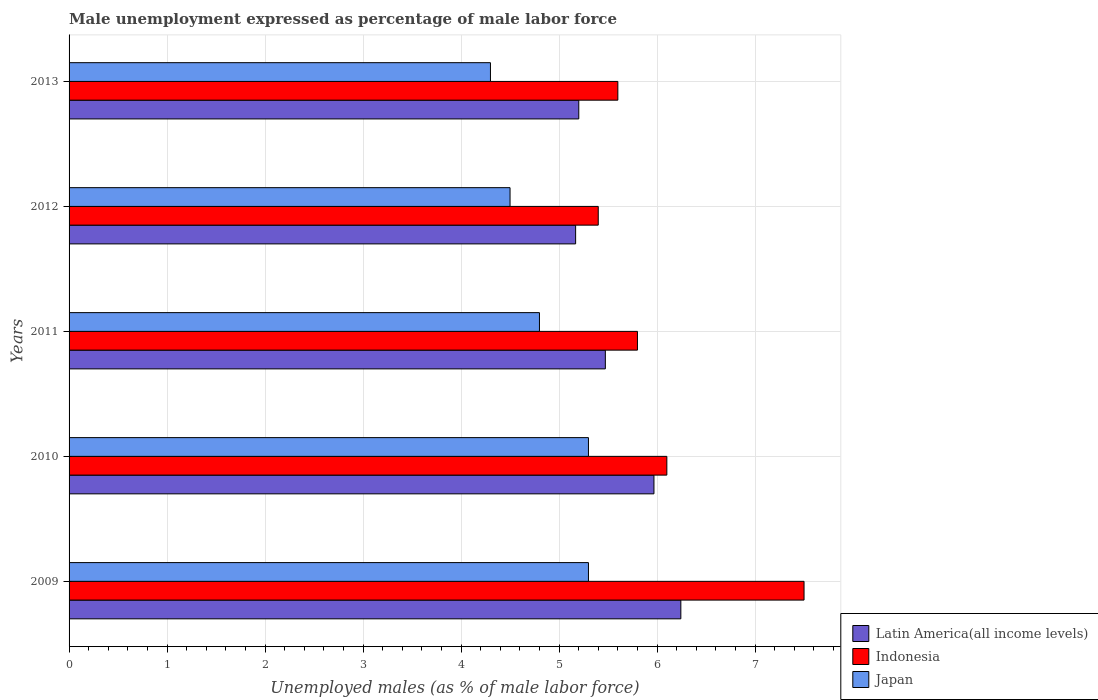How many groups of bars are there?
Offer a terse response. 5. Are the number of bars on each tick of the Y-axis equal?
Your answer should be compact. Yes. How many bars are there on the 4th tick from the bottom?
Give a very brief answer. 3. What is the label of the 4th group of bars from the top?
Your answer should be compact. 2010. In how many cases, is the number of bars for a given year not equal to the number of legend labels?
Your answer should be compact. 0. What is the unemployment in males in in Japan in 2011?
Offer a terse response. 4.8. Across all years, what is the maximum unemployment in males in in Japan?
Your response must be concise. 5.3. Across all years, what is the minimum unemployment in males in in Indonesia?
Make the answer very short. 5.4. In which year was the unemployment in males in in Japan maximum?
Provide a short and direct response. 2009. In which year was the unemployment in males in in Latin America(all income levels) minimum?
Your response must be concise. 2012. What is the total unemployment in males in in Latin America(all income levels) in the graph?
Your answer should be compact. 28.05. What is the difference between the unemployment in males in in Japan in 2010 and the unemployment in males in in Indonesia in 2011?
Give a very brief answer. -0.5. What is the average unemployment in males in in Japan per year?
Offer a terse response. 4.84. In the year 2013, what is the difference between the unemployment in males in in Indonesia and unemployment in males in in Japan?
Ensure brevity in your answer.  1.3. In how many years, is the unemployment in males in in Latin America(all income levels) greater than 3.4 %?
Provide a succinct answer. 5. What is the ratio of the unemployment in males in in Indonesia in 2011 to that in 2012?
Offer a very short reply. 1.07. Is the unemployment in males in in Indonesia in 2009 less than that in 2010?
Your response must be concise. No. Is the difference between the unemployment in males in in Indonesia in 2011 and 2012 greater than the difference between the unemployment in males in in Japan in 2011 and 2012?
Your response must be concise. Yes. What is the difference between the highest and the second highest unemployment in males in in Japan?
Give a very brief answer. 0. What is the difference between the highest and the lowest unemployment in males in in Indonesia?
Your response must be concise. 2.1. In how many years, is the unemployment in males in in Indonesia greater than the average unemployment in males in in Indonesia taken over all years?
Give a very brief answer. 2. What does the 3rd bar from the top in 2010 represents?
Your response must be concise. Latin America(all income levels). How many bars are there?
Ensure brevity in your answer.  15. How many years are there in the graph?
Keep it short and to the point. 5. What is the difference between two consecutive major ticks on the X-axis?
Provide a short and direct response. 1. Where does the legend appear in the graph?
Give a very brief answer. Bottom right. How are the legend labels stacked?
Make the answer very short. Vertical. What is the title of the graph?
Provide a succinct answer. Male unemployment expressed as percentage of male labor force. Does "Micronesia" appear as one of the legend labels in the graph?
Provide a succinct answer. No. What is the label or title of the X-axis?
Ensure brevity in your answer.  Unemployed males (as % of male labor force). What is the Unemployed males (as % of male labor force) of Latin America(all income levels) in 2009?
Offer a terse response. 6.24. What is the Unemployed males (as % of male labor force) in Japan in 2009?
Ensure brevity in your answer.  5.3. What is the Unemployed males (as % of male labor force) in Latin America(all income levels) in 2010?
Your answer should be compact. 5.97. What is the Unemployed males (as % of male labor force) in Indonesia in 2010?
Your answer should be compact. 6.1. What is the Unemployed males (as % of male labor force) of Japan in 2010?
Provide a short and direct response. 5.3. What is the Unemployed males (as % of male labor force) in Latin America(all income levels) in 2011?
Provide a succinct answer. 5.47. What is the Unemployed males (as % of male labor force) in Indonesia in 2011?
Give a very brief answer. 5.8. What is the Unemployed males (as % of male labor force) of Japan in 2011?
Your answer should be very brief. 4.8. What is the Unemployed males (as % of male labor force) of Latin America(all income levels) in 2012?
Provide a succinct answer. 5.17. What is the Unemployed males (as % of male labor force) of Indonesia in 2012?
Make the answer very short. 5.4. What is the Unemployed males (as % of male labor force) in Latin America(all income levels) in 2013?
Make the answer very short. 5.2. What is the Unemployed males (as % of male labor force) in Indonesia in 2013?
Offer a very short reply. 5.6. What is the Unemployed males (as % of male labor force) of Japan in 2013?
Give a very brief answer. 4.3. Across all years, what is the maximum Unemployed males (as % of male labor force) of Latin America(all income levels)?
Offer a terse response. 6.24. Across all years, what is the maximum Unemployed males (as % of male labor force) of Indonesia?
Offer a terse response. 7.5. Across all years, what is the maximum Unemployed males (as % of male labor force) in Japan?
Your response must be concise. 5.3. Across all years, what is the minimum Unemployed males (as % of male labor force) of Latin America(all income levels)?
Your response must be concise. 5.17. Across all years, what is the minimum Unemployed males (as % of male labor force) of Indonesia?
Offer a very short reply. 5.4. Across all years, what is the minimum Unemployed males (as % of male labor force) of Japan?
Your response must be concise. 4.3. What is the total Unemployed males (as % of male labor force) of Latin America(all income levels) in the graph?
Offer a very short reply. 28.05. What is the total Unemployed males (as % of male labor force) in Indonesia in the graph?
Provide a succinct answer. 30.4. What is the total Unemployed males (as % of male labor force) in Japan in the graph?
Provide a succinct answer. 24.2. What is the difference between the Unemployed males (as % of male labor force) of Latin America(all income levels) in 2009 and that in 2010?
Offer a very short reply. 0.27. What is the difference between the Unemployed males (as % of male labor force) in Japan in 2009 and that in 2010?
Your answer should be very brief. 0. What is the difference between the Unemployed males (as % of male labor force) in Latin America(all income levels) in 2009 and that in 2011?
Your answer should be very brief. 0.77. What is the difference between the Unemployed males (as % of male labor force) of Indonesia in 2009 and that in 2011?
Give a very brief answer. 1.7. What is the difference between the Unemployed males (as % of male labor force) in Japan in 2009 and that in 2011?
Make the answer very short. 0.5. What is the difference between the Unemployed males (as % of male labor force) of Latin America(all income levels) in 2009 and that in 2012?
Give a very brief answer. 1.07. What is the difference between the Unemployed males (as % of male labor force) of Indonesia in 2009 and that in 2012?
Make the answer very short. 2.1. What is the difference between the Unemployed males (as % of male labor force) of Japan in 2009 and that in 2012?
Offer a very short reply. 0.8. What is the difference between the Unemployed males (as % of male labor force) in Latin America(all income levels) in 2009 and that in 2013?
Your answer should be very brief. 1.04. What is the difference between the Unemployed males (as % of male labor force) in Indonesia in 2009 and that in 2013?
Make the answer very short. 1.9. What is the difference between the Unemployed males (as % of male labor force) of Latin America(all income levels) in 2010 and that in 2011?
Offer a very short reply. 0.5. What is the difference between the Unemployed males (as % of male labor force) in Latin America(all income levels) in 2010 and that in 2012?
Keep it short and to the point. 0.8. What is the difference between the Unemployed males (as % of male labor force) of Japan in 2010 and that in 2012?
Make the answer very short. 0.8. What is the difference between the Unemployed males (as % of male labor force) of Latin America(all income levels) in 2010 and that in 2013?
Make the answer very short. 0.77. What is the difference between the Unemployed males (as % of male labor force) of Indonesia in 2010 and that in 2013?
Keep it short and to the point. 0.5. What is the difference between the Unemployed males (as % of male labor force) of Japan in 2010 and that in 2013?
Your answer should be compact. 1. What is the difference between the Unemployed males (as % of male labor force) in Latin America(all income levels) in 2011 and that in 2012?
Ensure brevity in your answer.  0.3. What is the difference between the Unemployed males (as % of male labor force) in Indonesia in 2011 and that in 2012?
Your answer should be very brief. 0.4. What is the difference between the Unemployed males (as % of male labor force) in Japan in 2011 and that in 2012?
Offer a very short reply. 0.3. What is the difference between the Unemployed males (as % of male labor force) in Latin America(all income levels) in 2011 and that in 2013?
Your answer should be very brief. 0.27. What is the difference between the Unemployed males (as % of male labor force) in Japan in 2011 and that in 2013?
Offer a terse response. 0.5. What is the difference between the Unemployed males (as % of male labor force) of Latin America(all income levels) in 2012 and that in 2013?
Make the answer very short. -0.03. What is the difference between the Unemployed males (as % of male labor force) in Indonesia in 2012 and that in 2013?
Your answer should be very brief. -0.2. What is the difference between the Unemployed males (as % of male labor force) in Japan in 2012 and that in 2013?
Provide a succinct answer. 0.2. What is the difference between the Unemployed males (as % of male labor force) of Latin America(all income levels) in 2009 and the Unemployed males (as % of male labor force) of Indonesia in 2010?
Keep it short and to the point. 0.14. What is the difference between the Unemployed males (as % of male labor force) in Latin America(all income levels) in 2009 and the Unemployed males (as % of male labor force) in Japan in 2010?
Offer a terse response. 0.94. What is the difference between the Unemployed males (as % of male labor force) of Indonesia in 2009 and the Unemployed males (as % of male labor force) of Japan in 2010?
Provide a succinct answer. 2.2. What is the difference between the Unemployed males (as % of male labor force) of Latin America(all income levels) in 2009 and the Unemployed males (as % of male labor force) of Indonesia in 2011?
Your answer should be compact. 0.44. What is the difference between the Unemployed males (as % of male labor force) in Latin America(all income levels) in 2009 and the Unemployed males (as % of male labor force) in Japan in 2011?
Keep it short and to the point. 1.44. What is the difference between the Unemployed males (as % of male labor force) of Latin America(all income levels) in 2009 and the Unemployed males (as % of male labor force) of Indonesia in 2012?
Your answer should be very brief. 0.84. What is the difference between the Unemployed males (as % of male labor force) of Latin America(all income levels) in 2009 and the Unemployed males (as % of male labor force) of Japan in 2012?
Give a very brief answer. 1.74. What is the difference between the Unemployed males (as % of male labor force) in Indonesia in 2009 and the Unemployed males (as % of male labor force) in Japan in 2012?
Ensure brevity in your answer.  3. What is the difference between the Unemployed males (as % of male labor force) in Latin America(all income levels) in 2009 and the Unemployed males (as % of male labor force) in Indonesia in 2013?
Provide a short and direct response. 0.64. What is the difference between the Unemployed males (as % of male labor force) of Latin America(all income levels) in 2009 and the Unemployed males (as % of male labor force) of Japan in 2013?
Offer a very short reply. 1.94. What is the difference between the Unemployed males (as % of male labor force) in Latin America(all income levels) in 2010 and the Unemployed males (as % of male labor force) in Indonesia in 2011?
Ensure brevity in your answer.  0.17. What is the difference between the Unemployed males (as % of male labor force) of Latin America(all income levels) in 2010 and the Unemployed males (as % of male labor force) of Japan in 2011?
Make the answer very short. 1.17. What is the difference between the Unemployed males (as % of male labor force) in Latin America(all income levels) in 2010 and the Unemployed males (as % of male labor force) in Indonesia in 2012?
Give a very brief answer. 0.57. What is the difference between the Unemployed males (as % of male labor force) of Latin America(all income levels) in 2010 and the Unemployed males (as % of male labor force) of Japan in 2012?
Offer a very short reply. 1.47. What is the difference between the Unemployed males (as % of male labor force) of Indonesia in 2010 and the Unemployed males (as % of male labor force) of Japan in 2012?
Ensure brevity in your answer.  1.6. What is the difference between the Unemployed males (as % of male labor force) of Latin America(all income levels) in 2010 and the Unemployed males (as % of male labor force) of Indonesia in 2013?
Ensure brevity in your answer.  0.37. What is the difference between the Unemployed males (as % of male labor force) in Latin America(all income levels) in 2010 and the Unemployed males (as % of male labor force) in Japan in 2013?
Provide a short and direct response. 1.67. What is the difference between the Unemployed males (as % of male labor force) in Indonesia in 2010 and the Unemployed males (as % of male labor force) in Japan in 2013?
Your answer should be very brief. 1.8. What is the difference between the Unemployed males (as % of male labor force) in Latin America(all income levels) in 2011 and the Unemployed males (as % of male labor force) in Indonesia in 2012?
Keep it short and to the point. 0.07. What is the difference between the Unemployed males (as % of male labor force) of Latin America(all income levels) in 2011 and the Unemployed males (as % of male labor force) of Japan in 2012?
Your response must be concise. 0.97. What is the difference between the Unemployed males (as % of male labor force) of Latin America(all income levels) in 2011 and the Unemployed males (as % of male labor force) of Indonesia in 2013?
Give a very brief answer. -0.13. What is the difference between the Unemployed males (as % of male labor force) of Latin America(all income levels) in 2011 and the Unemployed males (as % of male labor force) of Japan in 2013?
Keep it short and to the point. 1.17. What is the difference between the Unemployed males (as % of male labor force) of Latin America(all income levels) in 2012 and the Unemployed males (as % of male labor force) of Indonesia in 2013?
Provide a short and direct response. -0.43. What is the difference between the Unemployed males (as % of male labor force) of Latin America(all income levels) in 2012 and the Unemployed males (as % of male labor force) of Japan in 2013?
Your answer should be compact. 0.87. What is the average Unemployed males (as % of male labor force) in Latin America(all income levels) per year?
Your answer should be very brief. 5.61. What is the average Unemployed males (as % of male labor force) in Indonesia per year?
Your answer should be compact. 6.08. What is the average Unemployed males (as % of male labor force) of Japan per year?
Your answer should be compact. 4.84. In the year 2009, what is the difference between the Unemployed males (as % of male labor force) of Latin America(all income levels) and Unemployed males (as % of male labor force) of Indonesia?
Offer a terse response. -1.26. In the year 2009, what is the difference between the Unemployed males (as % of male labor force) of Latin America(all income levels) and Unemployed males (as % of male labor force) of Japan?
Give a very brief answer. 0.94. In the year 2009, what is the difference between the Unemployed males (as % of male labor force) in Indonesia and Unemployed males (as % of male labor force) in Japan?
Provide a short and direct response. 2.2. In the year 2010, what is the difference between the Unemployed males (as % of male labor force) in Latin America(all income levels) and Unemployed males (as % of male labor force) in Indonesia?
Give a very brief answer. -0.13. In the year 2010, what is the difference between the Unemployed males (as % of male labor force) of Latin America(all income levels) and Unemployed males (as % of male labor force) of Japan?
Offer a very short reply. 0.67. In the year 2010, what is the difference between the Unemployed males (as % of male labor force) in Indonesia and Unemployed males (as % of male labor force) in Japan?
Provide a succinct answer. 0.8. In the year 2011, what is the difference between the Unemployed males (as % of male labor force) in Latin America(all income levels) and Unemployed males (as % of male labor force) in Indonesia?
Give a very brief answer. -0.33. In the year 2011, what is the difference between the Unemployed males (as % of male labor force) in Latin America(all income levels) and Unemployed males (as % of male labor force) in Japan?
Make the answer very short. 0.67. In the year 2012, what is the difference between the Unemployed males (as % of male labor force) of Latin America(all income levels) and Unemployed males (as % of male labor force) of Indonesia?
Provide a short and direct response. -0.23. In the year 2012, what is the difference between the Unemployed males (as % of male labor force) of Latin America(all income levels) and Unemployed males (as % of male labor force) of Japan?
Make the answer very short. 0.67. In the year 2013, what is the difference between the Unemployed males (as % of male labor force) of Latin America(all income levels) and Unemployed males (as % of male labor force) of Indonesia?
Give a very brief answer. -0.4. In the year 2013, what is the difference between the Unemployed males (as % of male labor force) of Latin America(all income levels) and Unemployed males (as % of male labor force) of Japan?
Provide a short and direct response. 0.9. In the year 2013, what is the difference between the Unemployed males (as % of male labor force) in Indonesia and Unemployed males (as % of male labor force) in Japan?
Provide a succinct answer. 1.3. What is the ratio of the Unemployed males (as % of male labor force) in Latin America(all income levels) in 2009 to that in 2010?
Your answer should be very brief. 1.05. What is the ratio of the Unemployed males (as % of male labor force) of Indonesia in 2009 to that in 2010?
Provide a succinct answer. 1.23. What is the ratio of the Unemployed males (as % of male labor force) of Latin America(all income levels) in 2009 to that in 2011?
Provide a succinct answer. 1.14. What is the ratio of the Unemployed males (as % of male labor force) in Indonesia in 2009 to that in 2011?
Ensure brevity in your answer.  1.29. What is the ratio of the Unemployed males (as % of male labor force) in Japan in 2009 to that in 2011?
Keep it short and to the point. 1.1. What is the ratio of the Unemployed males (as % of male labor force) of Latin America(all income levels) in 2009 to that in 2012?
Your answer should be compact. 1.21. What is the ratio of the Unemployed males (as % of male labor force) in Indonesia in 2009 to that in 2012?
Your response must be concise. 1.39. What is the ratio of the Unemployed males (as % of male labor force) of Japan in 2009 to that in 2012?
Your answer should be very brief. 1.18. What is the ratio of the Unemployed males (as % of male labor force) in Latin America(all income levels) in 2009 to that in 2013?
Provide a short and direct response. 1.2. What is the ratio of the Unemployed males (as % of male labor force) of Indonesia in 2009 to that in 2013?
Your response must be concise. 1.34. What is the ratio of the Unemployed males (as % of male labor force) in Japan in 2009 to that in 2013?
Keep it short and to the point. 1.23. What is the ratio of the Unemployed males (as % of male labor force) in Latin America(all income levels) in 2010 to that in 2011?
Offer a very short reply. 1.09. What is the ratio of the Unemployed males (as % of male labor force) in Indonesia in 2010 to that in 2011?
Make the answer very short. 1.05. What is the ratio of the Unemployed males (as % of male labor force) of Japan in 2010 to that in 2011?
Your response must be concise. 1.1. What is the ratio of the Unemployed males (as % of male labor force) in Latin America(all income levels) in 2010 to that in 2012?
Your response must be concise. 1.15. What is the ratio of the Unemployed males (as % of male labor force) of Indonesia in 2010 to that in 2012?
Provide a short and direct response. 1.13. What is the ratio of the Unemployed males (as % of male labor force) in Japan in 2010 to that in 2012?
Offer a very short reply. 1.18. What is the ratio of the Unemployed males (as % of male labor force) of Latin America(all income levels) in 2010 to that in 2013?
Your answer should be very brief. 1.15. What is the ratio of the Unemployed males (as % of male labor force) in Indonesia in 2010 to that in 2013?
Make the answer very short. 1.09. What is the ratio of the Unemployed males (as % of male labor force) of Japan in 2010 to that in 2013?
Your response must be concise. 1.23. What is the ratio of the Unemployed males (as % of male labor force) of Latin America(all income levels) in 2011 to that in 2012?
Give a very brief answer. 1.06. What is the ratio of the Unemployed males (as % of male labor force) in Indonesia in 2011 to that in 2012?
Keep it short and to the point. 1.07. What is the ratio of the Unemployed males (as % of male labor force) in Japan in 2011 to that in 2012?
Your response must be concise. 1.07. What is the ratio of the Unemployed males (as % of male labor force) of Latin America(all income levels) in 2011 to that in 2013?
Your response must be concise. 1.05. What is the ratio of the Unemployed males (as % of male labor force) of Indonesia in 2011 to that in 2013?
Keep it short and to the point. 1.04. What is the ratio of the Unemployed males (as % of male labor force) in Japan in 2011 to that in 2013?
Give a very brief answer. 1.12. What is the ratio of the Unemployed males (as % of male labor force) of Latin America(all income levels) in 2012 to that in 2013?
Provide a succinct answer. 0.99. What is the ratio of the Unemployed males (as % of male labor force) of Japan in 2012 to that in 2013?
Offer a terse response. 1.05. What is the difference between the highest and the second highest Unemployed males (as % of male labor force) of Latin America(all income levels)?
Give a very brief answer. 0.27. What is the difference between the highest and the lowest Unemployed males (as % of male labor force) in Latin America(all income levels)?
Offer a very short reply. 1.07. What is the difference between the highest and the lowest Unemployed males (as % of male labor force) of Indonesia?
Your response must be concise. 2.1. 